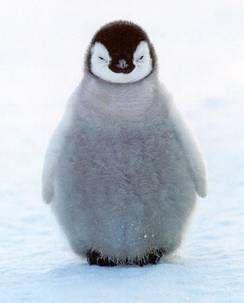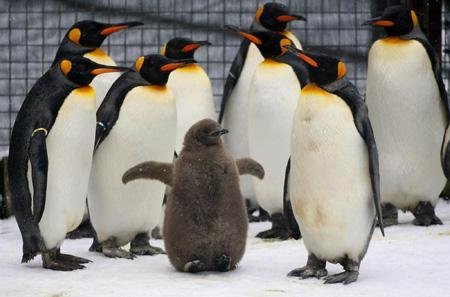The first image is the image on the left, the second image is the image on the right. Analyze the images presented: Is the assertion "One image includes a penguin with brown fuzzy feathers, and the other includes a gray fuzzy baby penguin." valid? Answer yes or no. Yes. The first image is the image on the left, the second image is the image on the right. For the images shown, is this caption "In one of the photos, one of the penguins is brown, and in the other, none of the penguins are brown." true? Answer yes or no. Yes. 